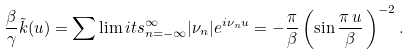Convert formula to latex. <formula><loc_0><loc_0><loc_500><loc_500>\frac { \beta } \gamma \tilde { k } ( u ) = \sum \lim i t s _ { n = - \infty } ^ { \infty } | \nu _ { n } | e ^ { i \nu _ { n } u } = - \frac { \pi } { \beta } \left ( \sin \frac { \pi \, u } { \beta } \, \right ) ^ { - 2 } .</formula> 